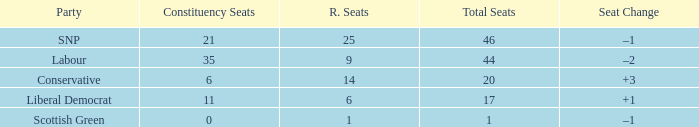How many regional seats were there with the SNP party and where the number of total seats was bigger than 46? 0.0. 